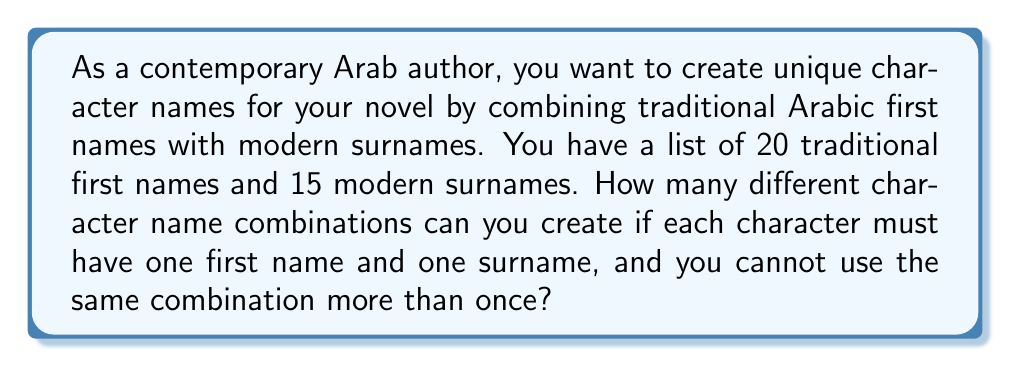What is the answer to this math problem? Let's approach this step-by-step:

1. We are dealing with a combination problem where we need to select one item from each of two distinct groups (first names and surnames) and pair them together.

2. The number of ways to select the first name:
   - There are 20 traditional first names to choose from.
   - We select 1 name at a time.
   - The selection of the first name can be done in 20 ways.

3. The number of ways to select the surname:
   - There are 15 modern surnames to choose from.
   - We select 1 surname at a time.
   - The selection of the surname can be done in 15 ways.

4. According to the Multiplication Principle, if we have m ways of doing one thing and n ways of doing another thing, then there are $m \times n$ ways of doing both things.

5. Therefore, the total number of possible character name combinations is:

   $$ \text{Total combinations} = \text{Number of first names} \times \text{Number of surnames} $$

   $$ \text{Total combinations} = 20 \times 15 = 300 $$

Thus, you can create 300 different character name combinations for your novel.
Answer: 300 combinations 